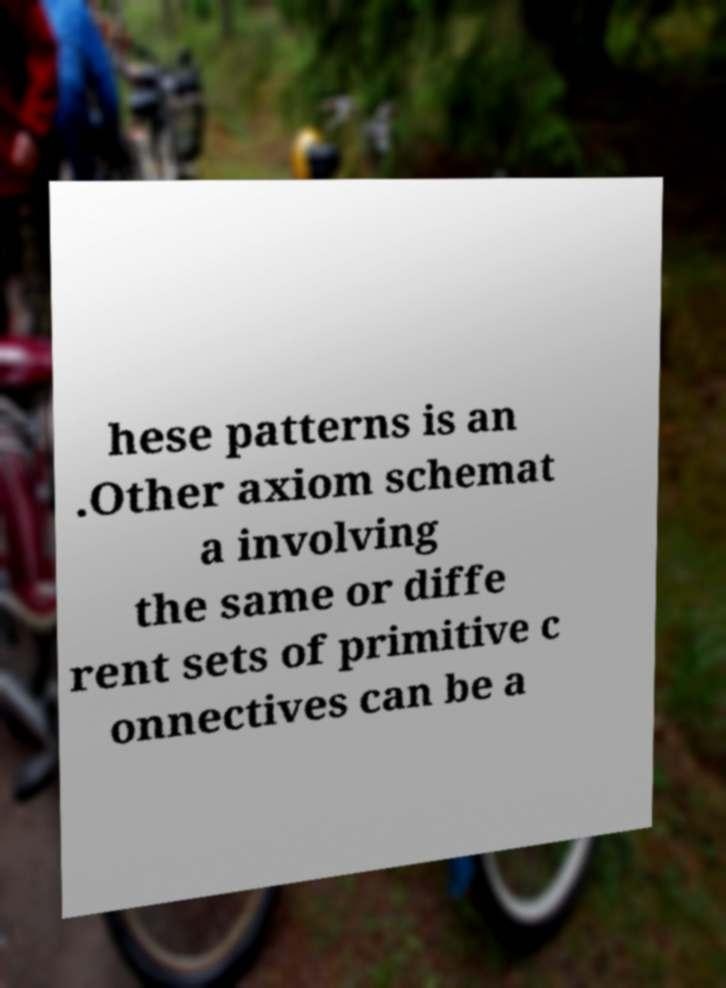Please identify and transcribe the text found in this image. hese patterns is an .Other axiom schemat a involving the same or diffe rent sets of primitive c onnectives can be a 